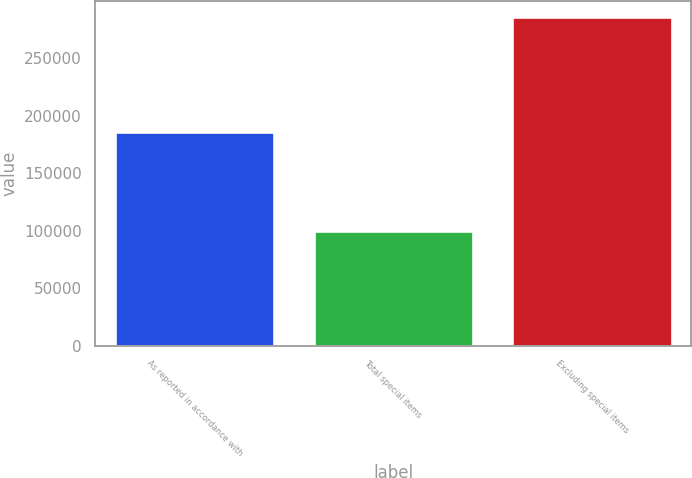<chart> <loc_0><loc_0><loc_500><loc_500><bar_chart><fcel>As reported in accordance with<fcel>Total special items<fcel>Excluding special items<nl><fcel>185382<fcel>100017<fcel>285399<nl></chart> 